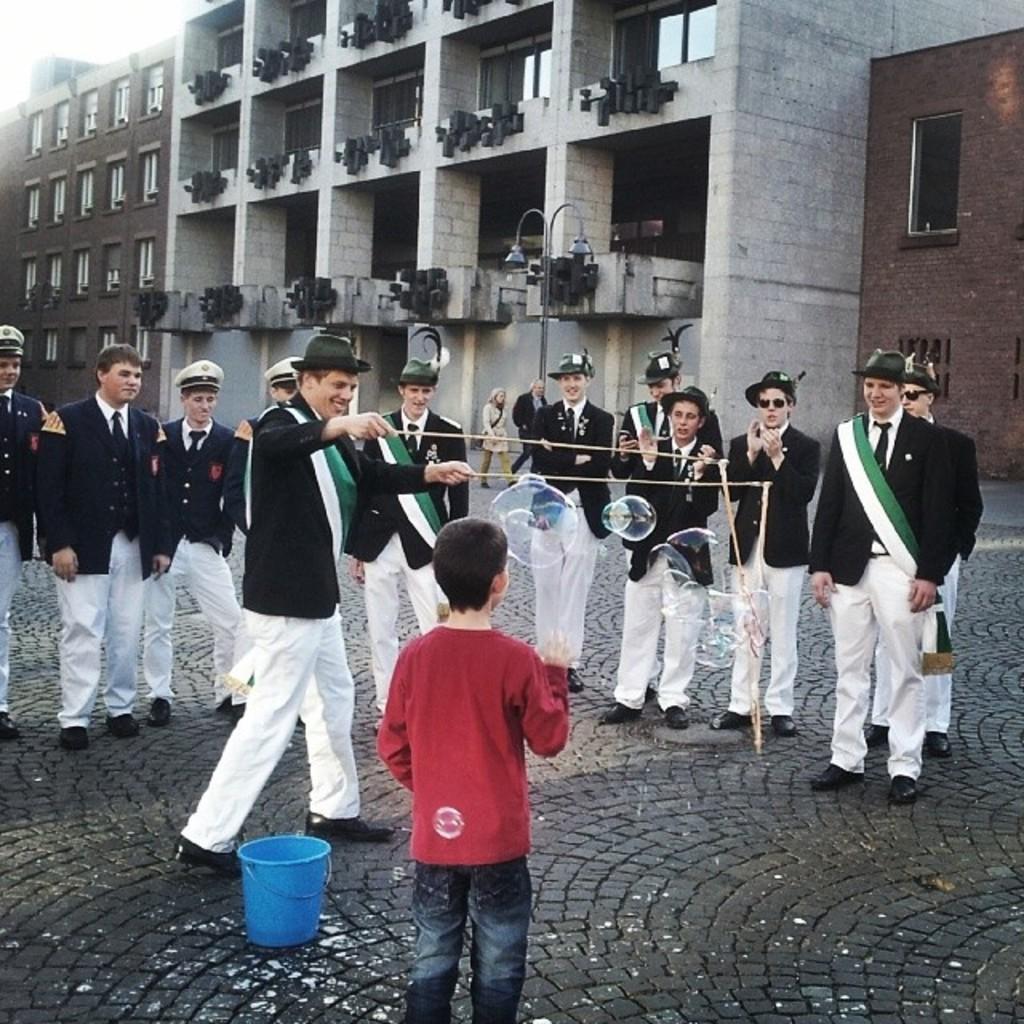Please provide a concise description of this image. In this picture there is a boy who is standing in the center of the image and there are people those who are standing in series in the center of the image, there is a bucket on the right side of the image, on the floor and there are buildings in the background area of the image. 